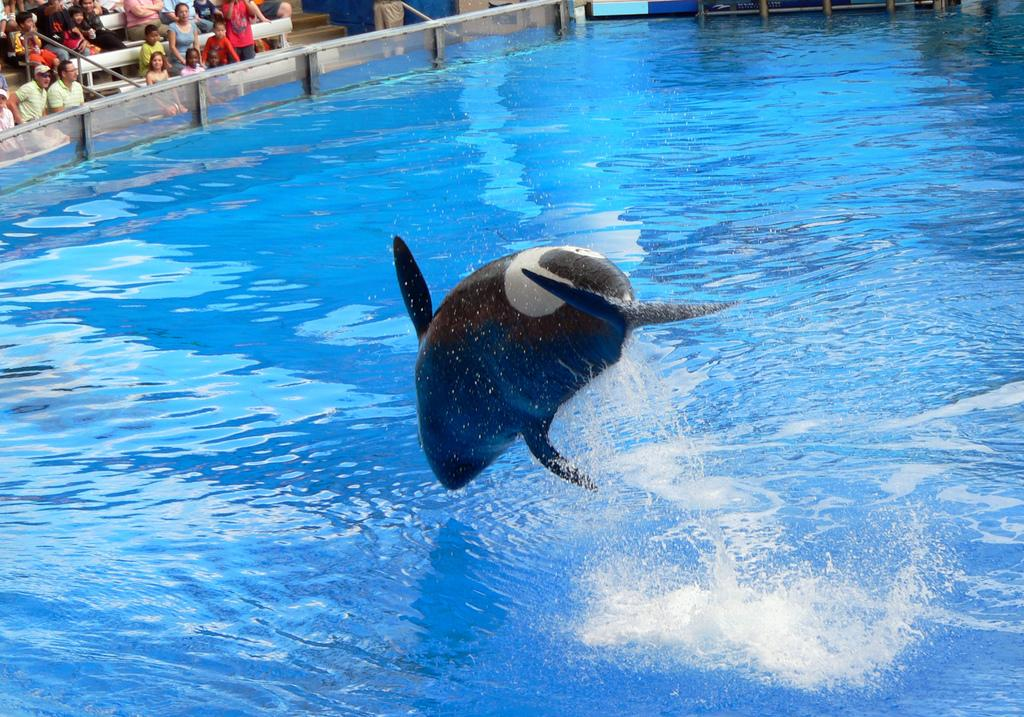What is the primary element in the image? There is water in the image. What type of animal can be seen in the water? There is a black-colored dolphin in the image. Can you describe the people in the background of the image? There are people sitting in the background of the image. What type of quince is being shaken in the garden in the image? There is no quince or garden present in the image; it features water with a black-colored dolphin and people sitting in the background. 